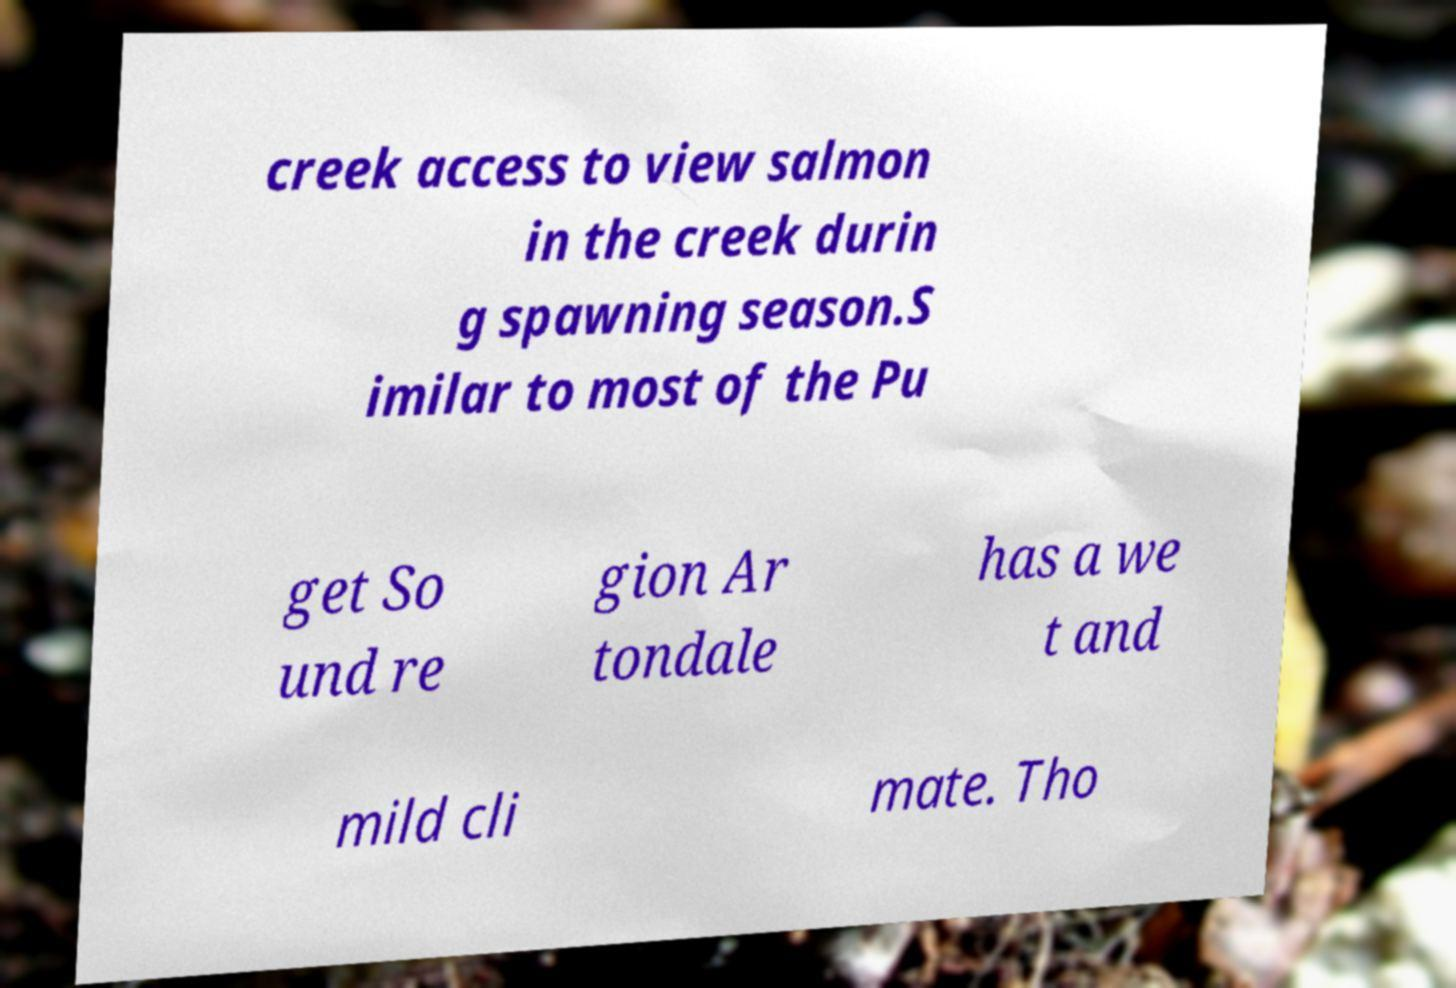I need the written content from this picture converted into text. Can you do that? creek access to view salmon in the creek durin g spawning season.S imilar to most of the Pu get So und re gion Ar tondale has a we t and mild cli mate. Tho 